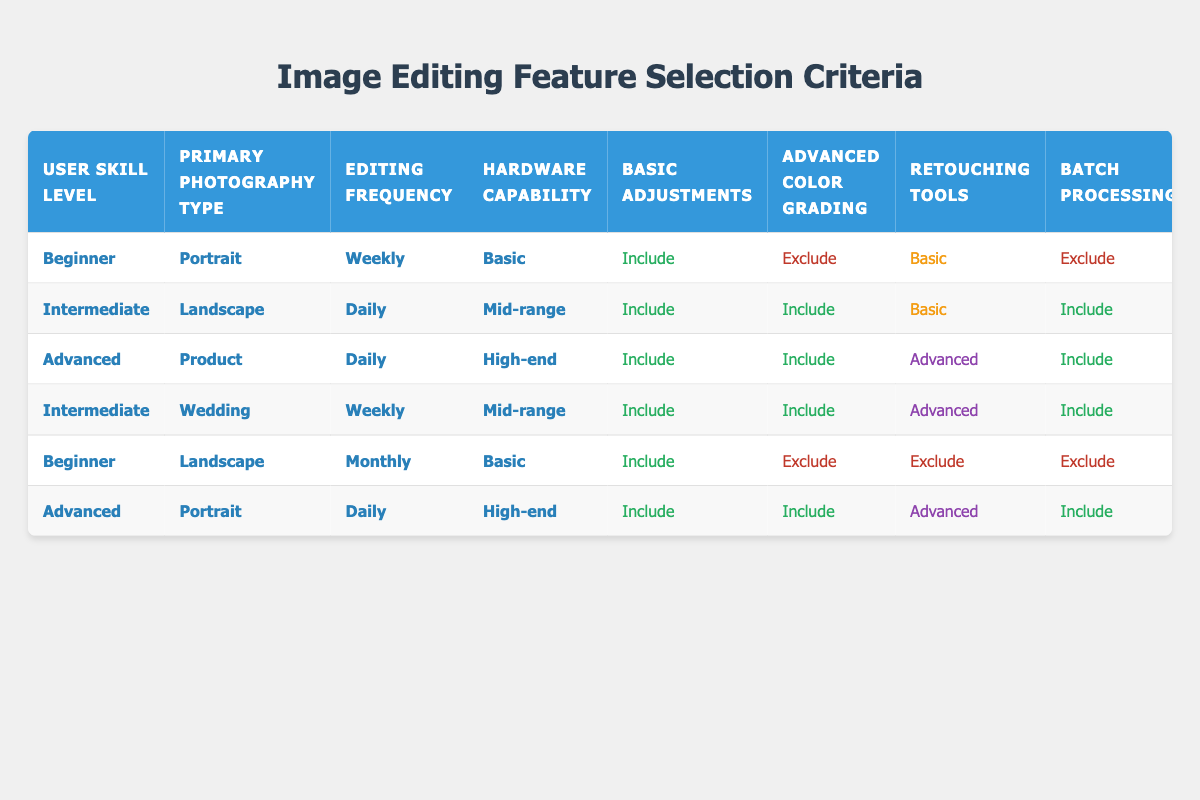What image editing features are included for Intermediate users who photograph Landscapes daily with Mid-range hardware? From the table, the row for Intermediate users, Landscape photography, Daily editing, and Mid-range hardware specifies that Basic Adjustments, Advanced Color Grading, Batch Processing, and Layer Management (Advanced) are included. Therefore, these features are available for this user group.
Answer: Basic Adjustments, Advanced Color Grading, Batch Processing, Layer Management (Advanced) Are Advanced users with High-end hardware allowed to use Basic Retouching Tools in their image editing software? By looking at the rows for Advanced users with High-end hardware, we see that the Retouching Tools specified are Advanced in both cases. This means Basic Retouching Tools are not included, as they are not suited for Advanced users who are expected to utilize Advanced tools.
Answer: No What features are excluded for Beginners editing Portraits Weekly on Basic hardware? The table shows that for Beginners editing Portraits Weekly with Basic hardware, Advanced Color Grading is excluded, Retouching Tools are Basic, and Batch Processing is excluded. This means the features excluded for them include Advanced Color Grading and Batch Processing.
Answer: Advanced Color Grading, Batch Processing How many editing features are included for Advanced users who primarily focus on Product photography and edit Daily? In the relevant row of the table, Advanced users focusing on Product photography with Daily editing have Basic Adjustments, Advanced Color Grading, Retouching Tools (Advanced), Batch Processing, RAW Processing, Layer Management (Advanced), Presets and Filters, and AI-powered Enhancements included. This sums up to a total of 8 features included.
Answer: 8 Is it true that all editing features are included for Intermediate Wedding photographers who edit Weekly using Mid-range hardware? By checking the row for Intermediate Wedding photographers who edit Weekly with Mid-range hardware, we can see that all features are indeed included, as both Basic Adjustments, Advanced Color Grading, Retouching Tools (Advanced), Batch Processing, RAW Processing, Layer Management (Basic), Presets and Filters, and AI-powered Enhancements show as included.
Answer: Yes What differences in editing features can be identified between Beginners and Advanced users focusing on Portraits with High-end hardware? Analyzing the rows for Beginners and Advanced users focusing on Portraits with High-end hardware shows that Beginners have the following features: Basic Adjustments (Included), Advanced Color Grading (Excluded), Retouching Tools (Basic), Layer Management (Basic), with Batch Processing and AI-powered Enhancements excluded. In contrast, Advanced users have all features included. This highlights that Advanced users have access to all the advanced tools while Beginners do not.
Answer: Advanced users have all features included; Beginners do not What types of processing are included for Intermediate users who photograph Landscapes daily with Mid-range hardware? From the table, Intermediate users who take Landscape photos daily with Mid-range hardware have RAW Processing, and Batch Processing included.
Answer: RAW Processing, Batch Processing 